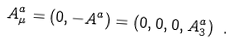Convert formula to latex. <formula><loc_0><loc_0><loc_500><loc_500>A _ { \mu } ^ { a } = ( 0 , - { A } ^ { a } ) = ( 0 , 0 , 0 , A _ { 3 } ^ { a } ) \ .</formula> 